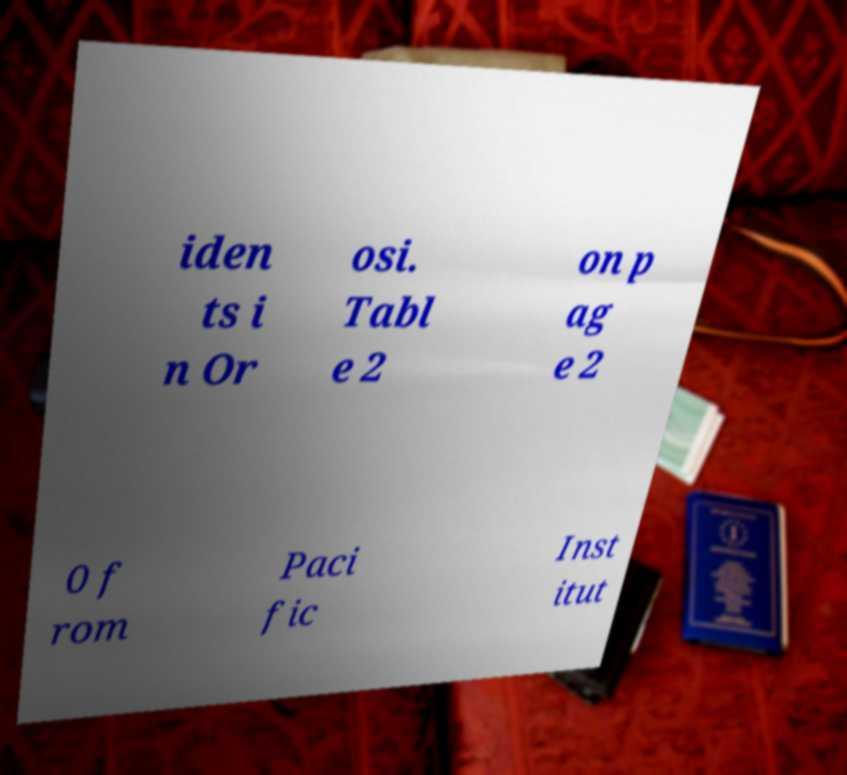Could you extract and type out the text from this image? iden ts i n Or osi. Tabl e 2 on p ag e 2 0 f rom Paci fic Inst itut 